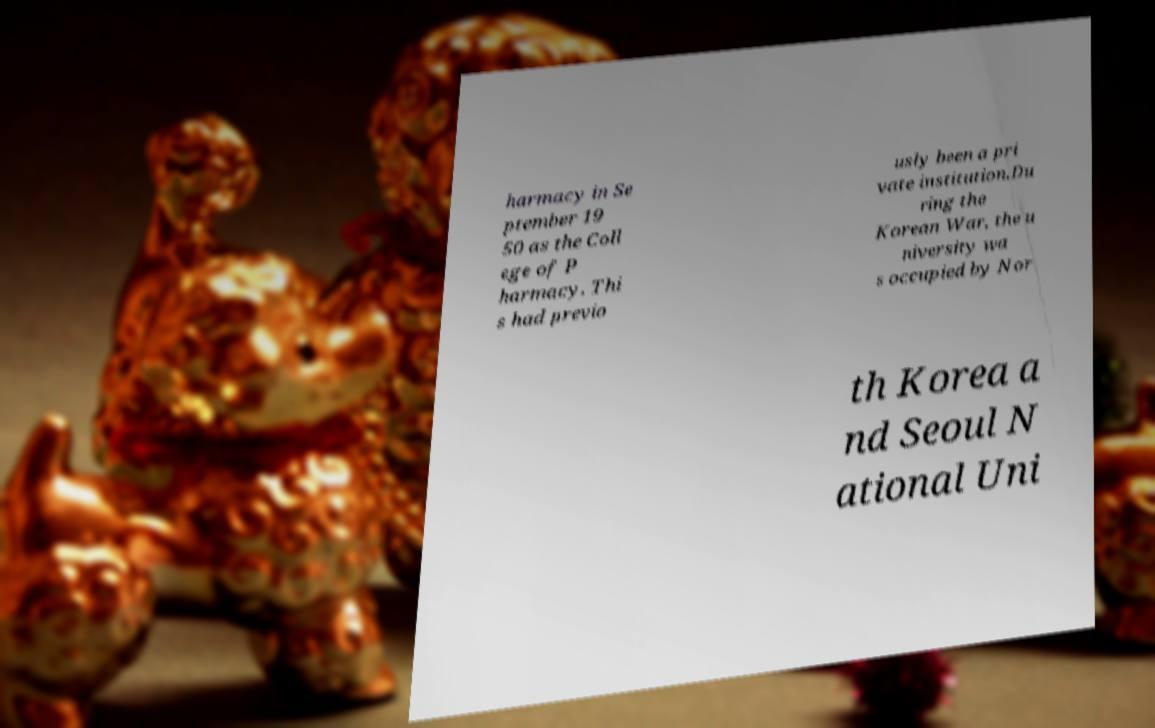What messages or text are displayed in this image? I need them in a readable, typed format. harmacy in Se ptember 19 50 as the Coll ege of P harmacy. Thi s had previo usly been a pri vate institution.Du ring the Korean War, the u niversity wa s occupied by Nor th Korea a nd Seoul N ational Uni 